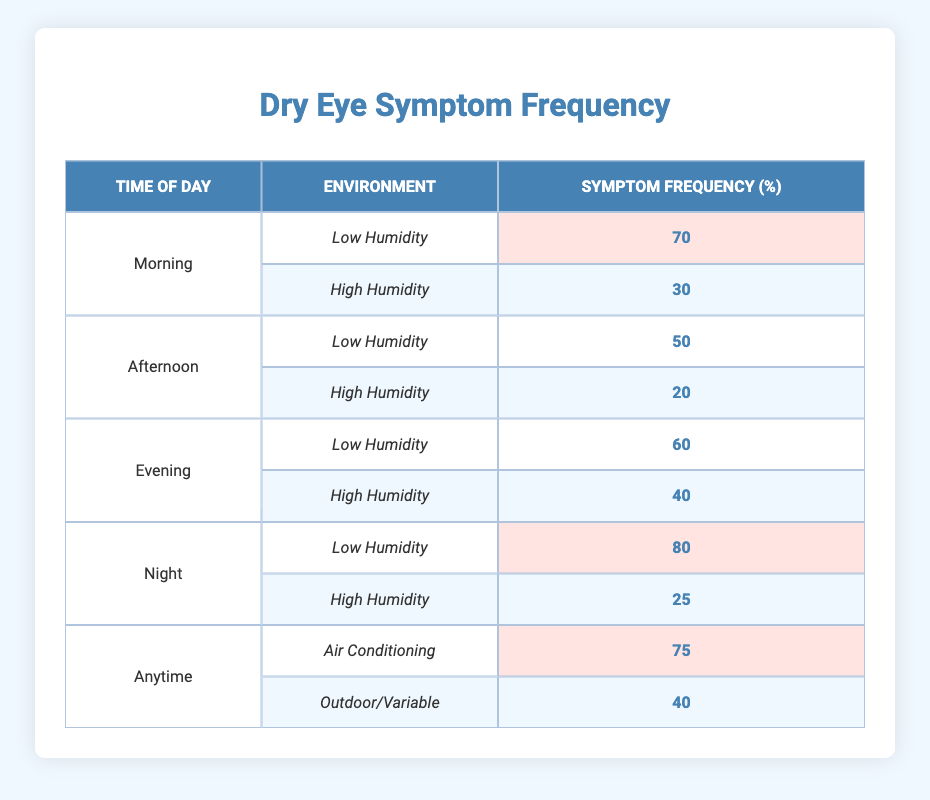What is the symptom frequency in the morning during low humidity? According to the table, the symptom frequency during the morning with low humidity is listed as 70%.
Answer: 70% What is the highest symptom frequency recorded? The table indicates that the highest symptom frequency occurs at night in low humidity, recorded at 80%.
Answer: 80% What is the average symptom frequency for high humidity across all times of day? To find the average for high humidity, the values are: 30 (morning) + 20 (afternoon) + 40 (evening) + 25 (night) = 115. There are 4 data points, so the average is 115/4 = 28.75%.
Answer: 28.75% During which time of day is the symptom frequency lowest in high humidity? Evaluating the high humidity across times of day, the frequencies are: 30% (morning), 20% (afternoon), 40% (evening), and 25% (night). The lowest value is 20% in the afternoon.
Answer: 20% Is the symptom frequency higher for low humidity or high humidity in the evening? For evening low humidity, the frequency is 60%, while for high humidity it is 40%. Therefore, low humidity has a higher frequency.
Answer: Yes 